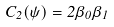Convert formula to latex. <formula><loc_0><loc_0><loc_500><loc_500>C _ { 2 } ( \psi ) = 2 \beta _ { 0 } \beta _ { 1 }</formula> 